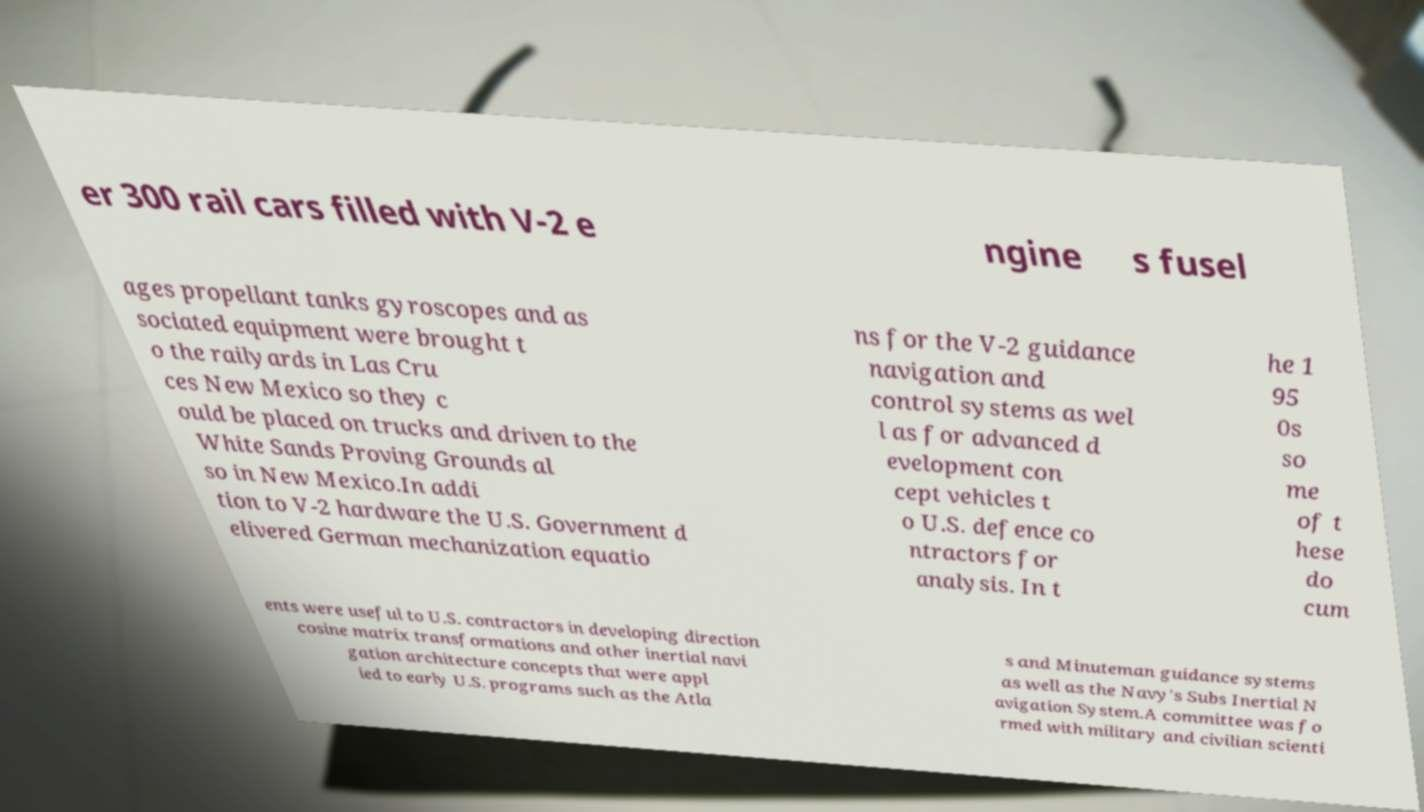For documentation purposes, I need the text within this image transcribed. Could you provide that? er 300 rail cars filled with V-2 e ngine s fusel ages propellant tanks gyroscopes and as sociated equipment were brought t o the railyards in Las Cru ces New Mexico so they c ould be placed on trucks and driven to the White Sands Proving Grounds al so in New Mexico.In addi tion to V-2 hardware the U.S. Government d elivered German mechanization equatio ns for the V-2 guidance navigation and control systems as wel l as for advanced d evelopment con cept vehicles t o U.S. defence co ntractors for analysis. In t he 1 95 0s so me of t hese do cum ents were useful to U.S. contractors in developing direction cosine matrix transformations and other inertial navi gation architecture concepts that were appl ied to early U.S. programs such as the Atla s and Minuteman guidance systems as well as the Navy's Subs Inertial N avigation System.A committee was fo rmed with military and civilian scienti 